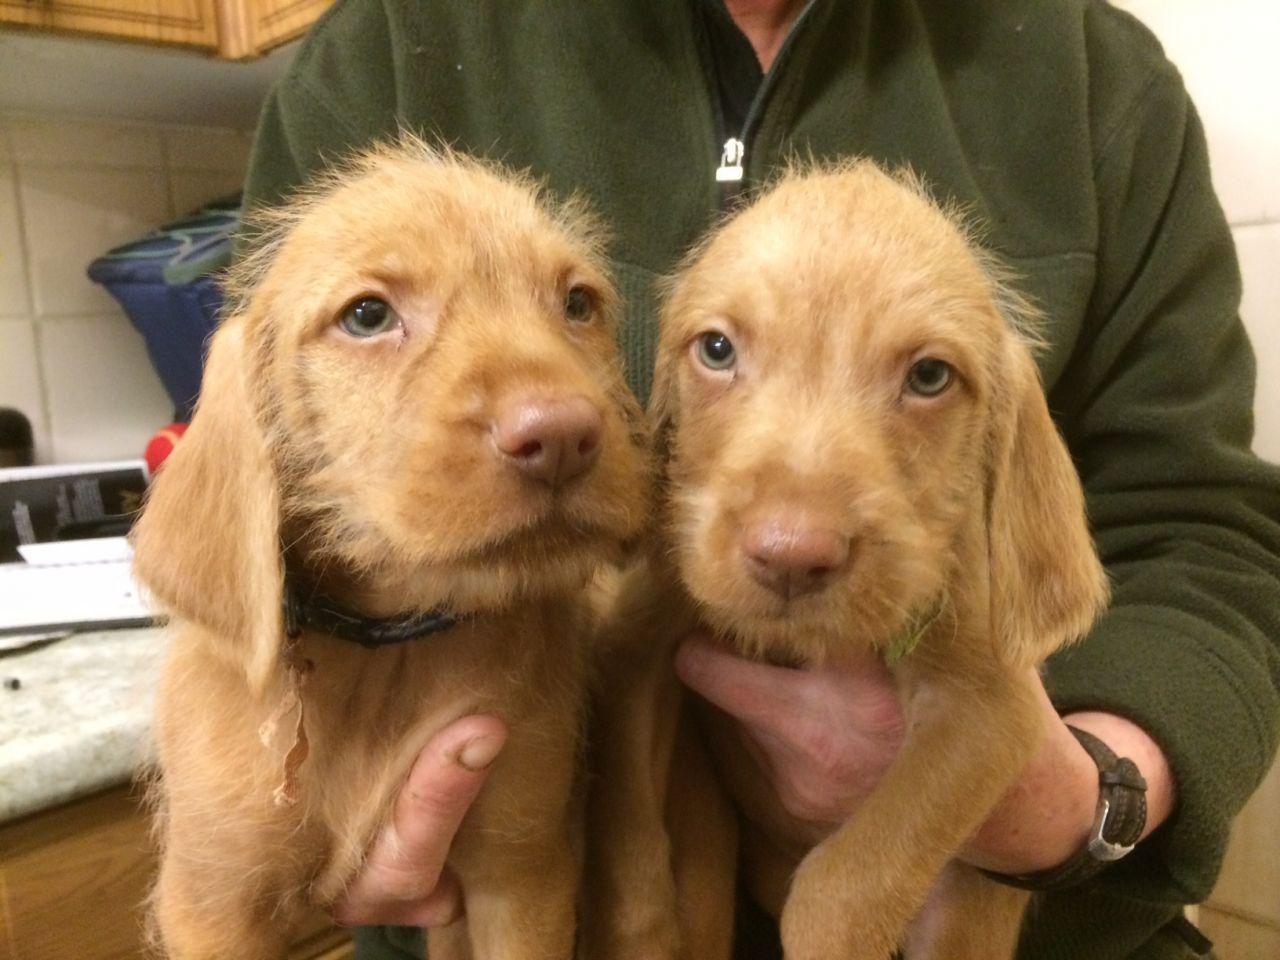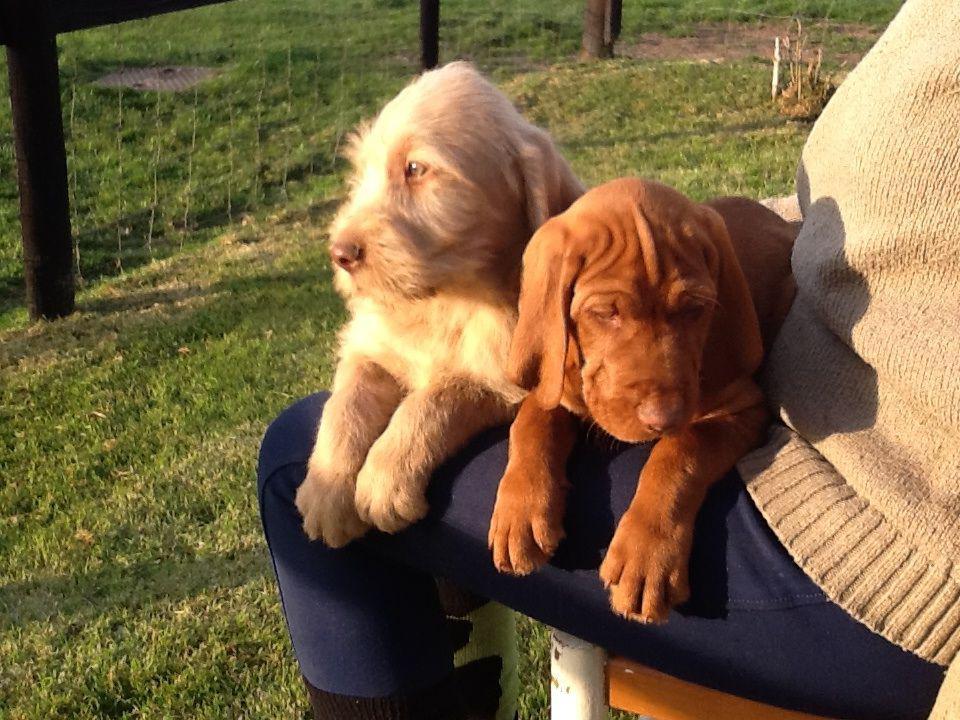The first image is the image on the left, the second image is the image on the right. Analyze the images presented: Is the assertion "The right image shows one forward-looking puppy standing on grass with the front paw on the left raised." valid? Answer yes or no. No. 